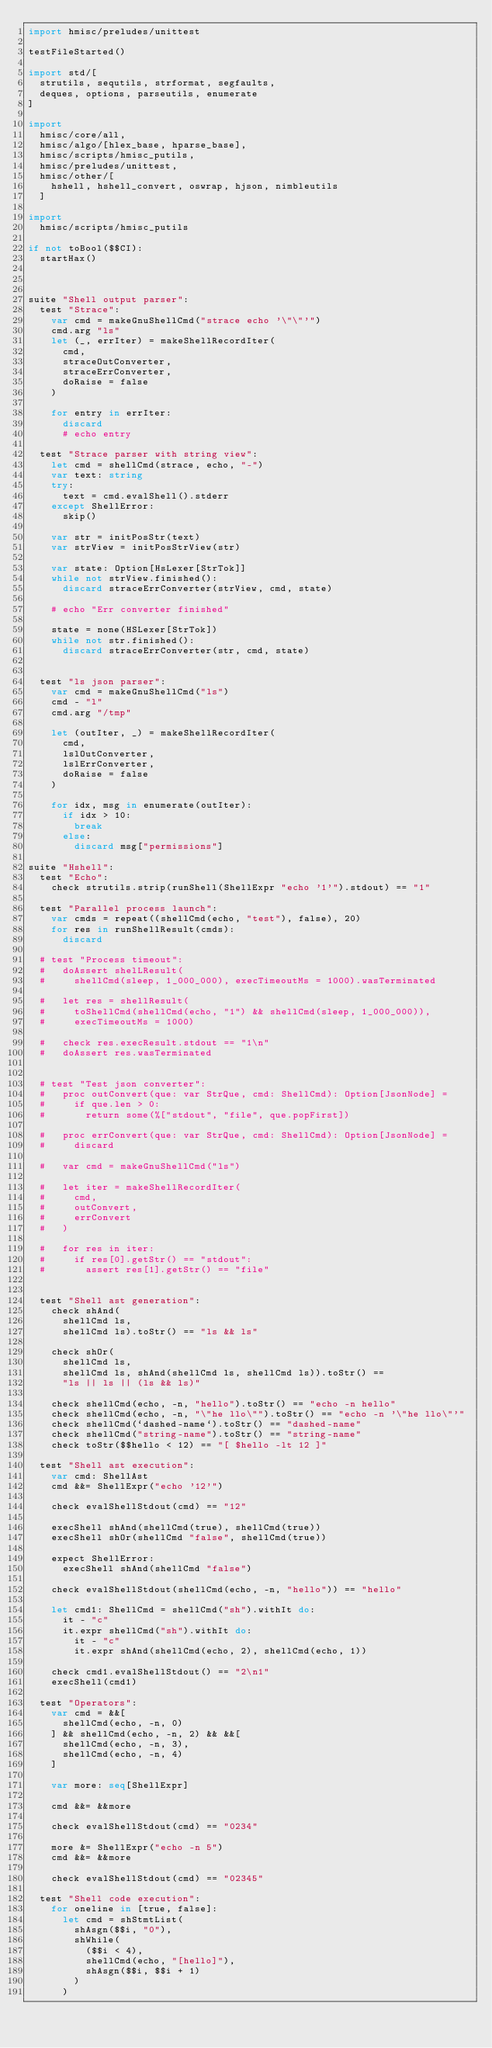<code> <loc_0><loc_0><loc_500><loc_500><_Nim_>import hmisc/preludes/unittest

testFileStarted()

import std/[
  strutils, sequtils, strformat, segfaults,
  deques, options, parseutils, enumerate
]

import
  hmisc/core/all,
  hmisc/algo/[hlex_base, hparse_base],
  hmisc/scripts/hmisc_putils,
  hmisc/preludes/unittest,
  hmisc/other/[
    hshell, hshell_convert, oswrap, hjson, nimbleutils
  ]

import
  hmisc/scripts/hmisc_putils

if not toBool($$CI):
  startHax()



suite "Shell output parser":
  test "Strace":
    var cmd = makeGnuShellCmd("strace echo '\"\"'")
    cmd.arg "ls"
    let (_, errIter) = makeShellRecordIter(
      cmd,
      straceOutConverter,
      straceErrConverter,
      doRaise = false
    )

    for entry in errIter:
      discard
      # echo entry

  test "Strace parser with string view":
    let cmd = shellCmd(strace, echo, "-")
    var text: string
    try:
      text = cmd.evalShell().stderr
    except ShellError:
      skip()

    var str = initPosStr(text)
    var strView = initPosStrView(str)

    var state: Option[HsLexer[StrTok]]
    while not strView.finished():
      discard straceErrConverter(strView, cmd, state)

    # echo "Err converter finished"

    state = none(HSLexer[StrTok])
    while not str.finished():
      discard straceErrConverter(str, cmd, state)


  test "ls json parser":
    var cmd = makeGnuShellCmd("ls")
    cmd - "l"
    cmd.arg "/tmp"

    let (outIter, _) = makeShellRecordIter(
      cmd,
      lslOutConverter,
      lslErrConverter,
      doRaise = false
    )

    for idx, msg in enumerate(outIter):
      if idx > 10:
        break
      else:
        discard msg["permissions"]

suite "Hshell":
  test "Echo":
    check strutils.strip(runShell(ShellExpr "echo '1'").stdout) == "1"

  test "Parallel process launch":
    var cmds = repeat((shellCmd(echo, "test"), false), 20)
    for res in runShellResult(cmds):
      discard

  # test "Process timeout":
  #   doAssert shelLResult(
  #     shellCmd(sleep, 1_000_000), execTimeoutMs = 1000).wasTerminated

  #   let res = shellResult(
  #     toShellCmd(shellCmd(echo, "1") && shellCmd(sleep, 1_000_000)),
  #     execTimeoutMs = 1000)

  #   check res.execResult.stdout == "1\n"
  #   doAssert res.wasTerminated


  # test "Test json converter":
  #   proc outConvert(que: var StrQue, cmd: ShellCmd): Option[JsonNode] =
  #     if que.len > 0:
  #       return some(%["stdout", "file", que.popFirst])

  #   proc errConvert(que: var StrQue, cmd: ShellCmd): Option[JsonNode] =
  #     discard

  #   var cmd = makeGnuShellCmd("ls")

  #   let iter = makeShellRecordIter(
  #     cmd,
  #     outConvert,
  #     errConvert
  #   )

  #   for res in iter:
  #     if res[0].getStr() == "stdout":
  #       assert res[1].getStr() == "file"


  test "Shell ast generation":
    check shAnd(
      shellCmd ls,
      shellCmd ls).toStr() == "ls && ls"

    check shOr(
      shellCmd ls,
      shellCmd ls, shAnd(shellCmd ls, shellCmd ls)).toStr() ==
      "ls || ls || (ls && ls)"

    check shellCmd(echo, -n, "hello").toStr() == "echo -n hello"
    check shellCmd(echo, -n, "\"he llo\"").toStr() == "echo -n '\"he llo\"'"
    check shellCmd(`dashed-name`).toStr() == "dashed-name"
    check shellCmd("string-name").toStr() == "string-name"
    check toStr($$hello < 12) == "[ $hello -lt 12 ]"

  test "Shell ast execution":
    var cmd: ShellAst
    cmd &&= ShellExpr("echo '12'")

    check evalShellStdout(cmd) == "12"

    execShell shAnd(shellCmd(true), shellCmd(true))
    execShell shOr(shellCmd "false", shellCmd(true))

    expect ShellError:
      execShell shAnd(shellCmd "false")

    check evalShellStdout(shellCmd(echo, -n, "hello")) == "hello"

    let cmd1: ShellCmd = shellCmd("sh").withIt do:
      it - "c"
      it.expr shellCmd("sh").withIt do:
        it - "c"
        it.expr shAnd(shellCmd(echo, 2), shellCmd(echo, 1))

    check cmd1.evalShellStdout() == "2\n1"
    execShell(cmd1)

  test "Operators":
    var cmd = &&[
      shellCmd(echo, -n, 0)
    ] && shellCmd(echo, -n, 2) && &&[
      shellCmd(echo, -n, 3),
      shellCmd(echo, -n, 4)
    ]

    var more: seq[ShellExpr]

    cmd &&= &&more

    check evalShellStdout(cmd) == "0234"

    more &= ShellExpr("echo -n 5")
    cmd &&= &&more

    check evalShellStdout(cmd) == "02345"

  test "Shell code execution":
    for oneline in [true, false]:
      let cmd = shStmtList(
        shAsgn($$i, "0"),
        shWhile(
          ($$i < 4),
          shellCmd(echo, "[hello]"),
          shAsgn($$i, $$i + 1)
        )
      )
</code> 